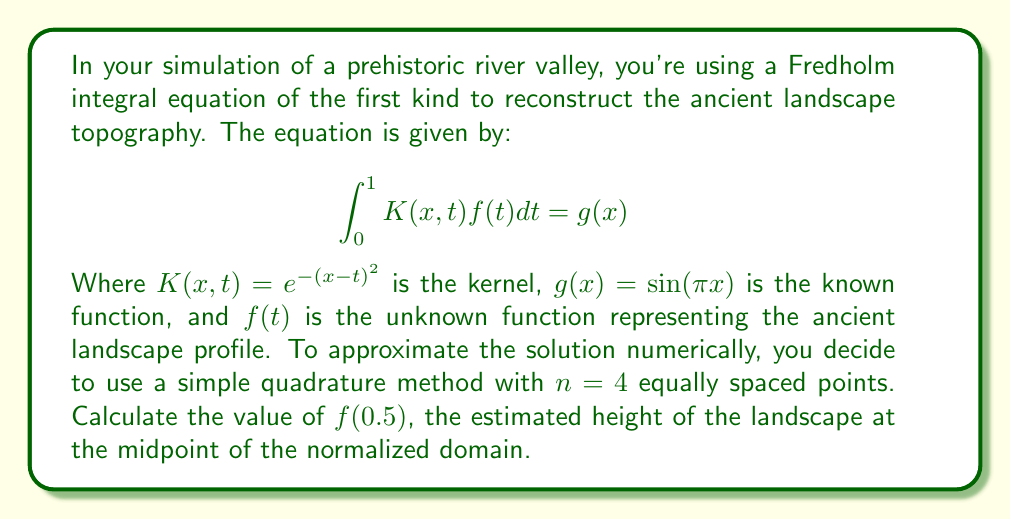Can you solve this math problem? To solve this problem, we'll follow these steps:

1) First, we'll discretize the integral equation using the simple quadrature method with $n=4$ points.

2) The quadrature points are $t_i = (i-0.5)/n$ for $i=1,2,3,4$. So, $t_1=0.125$, $t_2=0.375$, $t_3=0.625$, $t_4=0.875$.

3) We'll evaluate the equation at these same points for $x$, giving us a system of 4 linear equations:

   $$\sum_{j=1}^4 w_j K(x_i,t_j)f(t_j) = g(x_i)$$

   where $w_j = 1/n = 0.25$ are the quadrature weights.

4) This gives us the linear system $Af=b$, where:

   $$A_{ij} = 0.25 e^{-(x_i-t_j)^2}$$
   $$b_i = \sin(\pi x_i)$$

5) We can compute the matrix $A$ and vector $b$:

   $$A \approx \begin{bmatrix}
   0.2403 & 0.1920 & 0.1283 & 0.0718 \\
   0.1920 & 0.2403 & 0.1920 & 0.1283 \\
   0.1283 & 0.1920 & 0.2403 & 0.1920 \\
   0.0718 & 0.1283 & 0.1920 & 0.2403
   \end{bmatrix}$$

   $$b \approx \begin{bmatrix}
   0.3827 \\
   0.9239 \\
   0.9239 \\
   0.3827
   \end{bmatrix}$$

6) We can solve this system using a numerical method (e.g., Gaussian elimination or matrix inversion) to find $f$:

   $$f \approx \begin{bmatrix}
   1.3616 \\
   3.3914 \\
   3.3914 \\
   1.3616
   \end{bmatrix}$$

7) The value we're looking for, $f(0.5)$, can be approximated by interpolating between $f(t_2)$ and $f(t_3)$:

   $$f(0.5) \approx \frac{f(t_2) + f(t_3)}{2} = \frac{3.3914 + 3.3914}{2} = 3.3914$$
Answer: 3.3914 